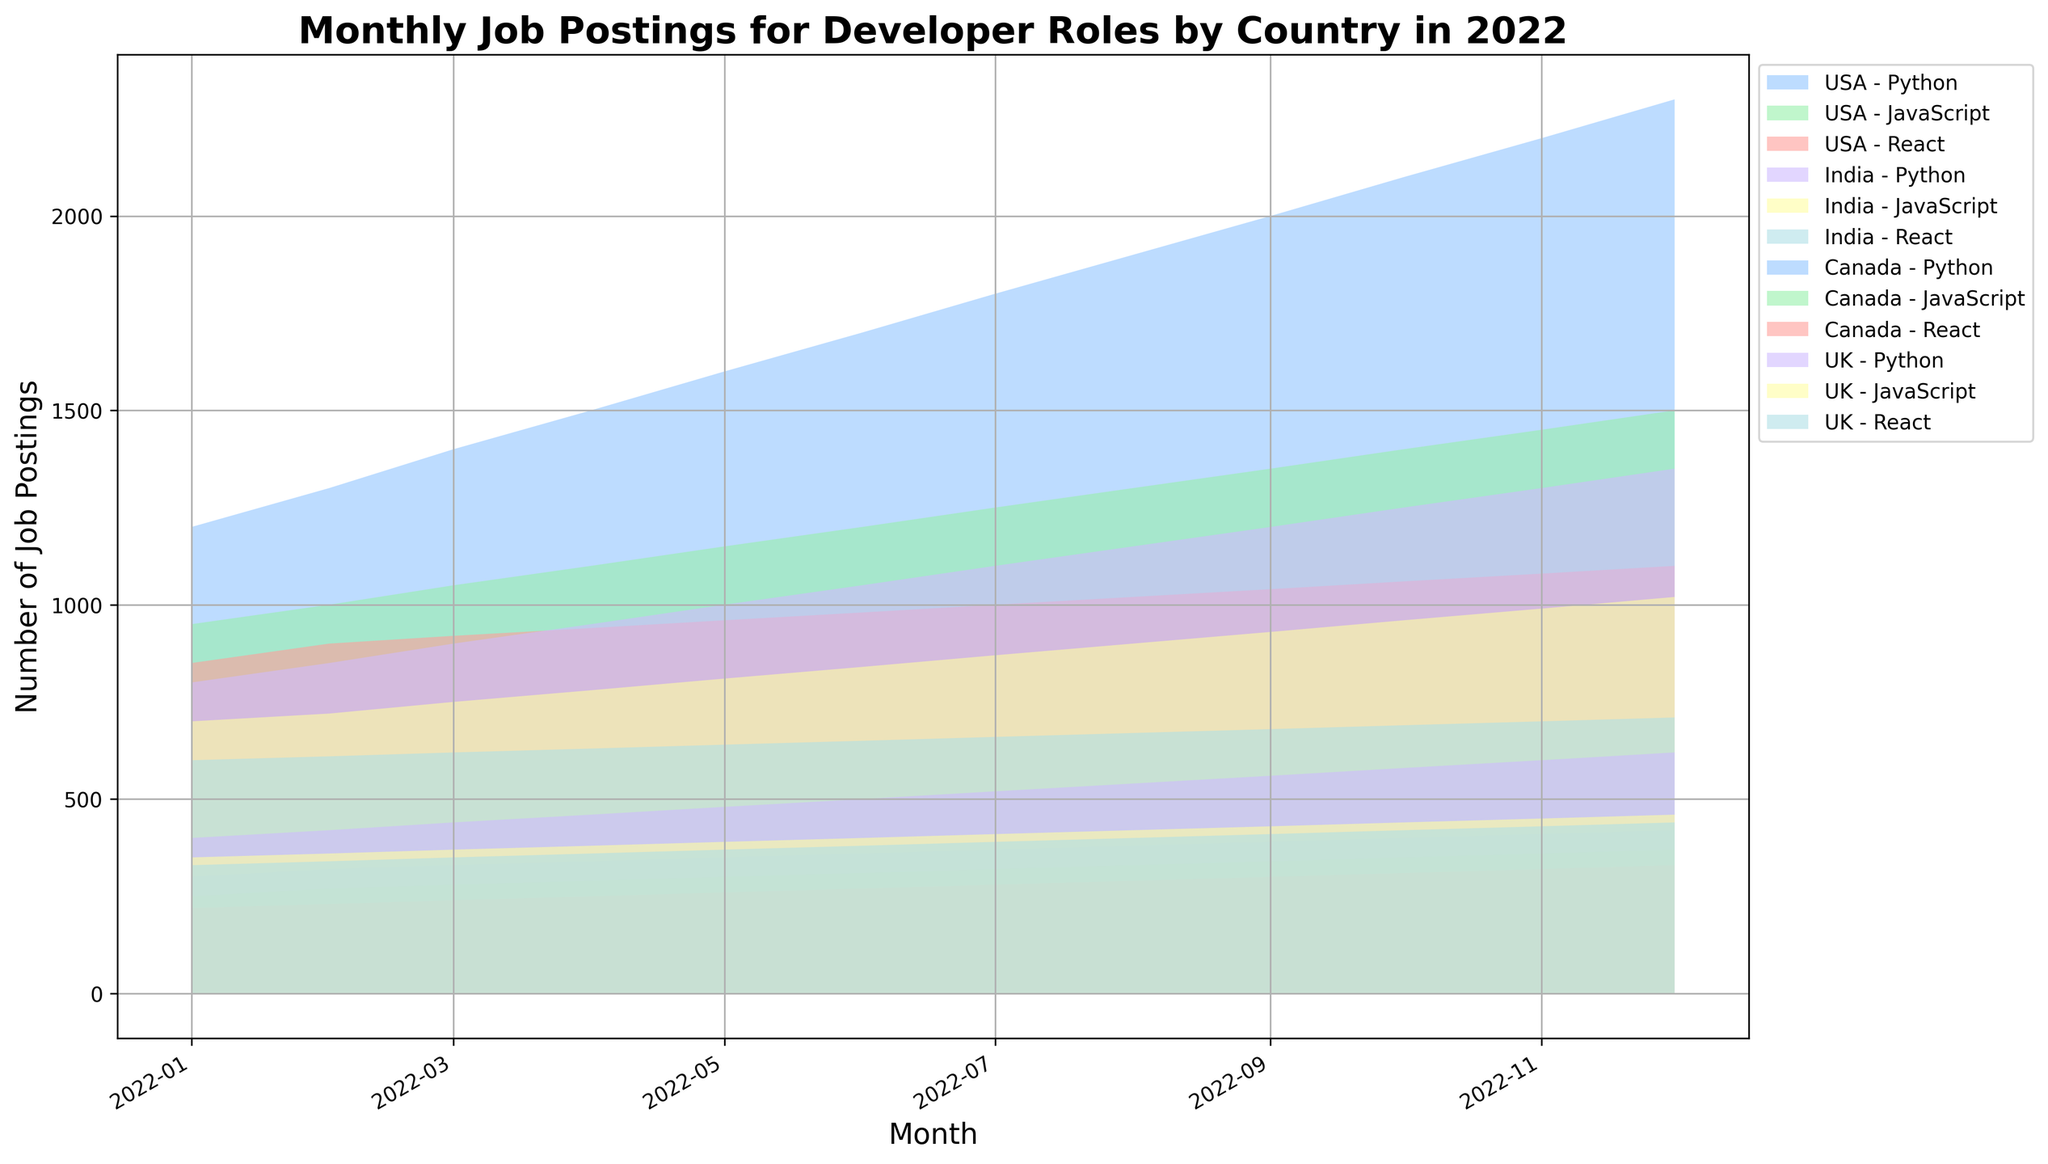Which country had the highest number of Python job postings in December 2022? Looking at the graph for December 2022, identify the height of the area marked for Python job postings for each country. The USA's area is the tallest.
Answer: USA How did the number of JavaScript job postings in India change from January to December 2022? Identify the beginning and end of the period (January and December) for JavaScript job postings in India. January has 700 job postings and December has 1020 job postings, indicating an increase.
Answer: Increased Which country showed the least growth in React job postings over the year 2022? Look for the smallest difference in the height of the area representing React job postings from January to December for each country. Canada shows the smallest increase.
Answer: Canada What is the total number of job postings (Python, JavaScript, and React combined) in the UK in April 2022? For April 2022 in the UK, sum the values of Python (460), JavaScript (380), and React (360) job postings. 460 + 380 + 360 = 1200.
Answer: 1200 Did the number of job postings for all roles (Python, JavaScript, and React) in the USA decrease at any time during 2022? Check the trend for the USA where the combined areas for Python, JavaScript, and React decrease from one month to the next. There is no decrease; the trend only increases.
Answer: No How do the Python job postings in Canada in March 2022 compare to those in India in the same month? Compare the height of the area for Python job postings for Canada and India in March 2022. Canada has 330 job postings, and India has 900 job postings, making India's higher.
Answer: India has more Which month had the highest combined number of job postings for all roles in the USA? Identify the month where the sum of the heights for Python, JavaScript, and React job postings in the USA is the largest. December 2022 has the highest combined number.
Answer: December 2022 How much did the number of React job postings in the UK increase from January to December 2022? Determine the number of React job postings in the UK for January (330) and December (440), then calculate the difference: 440 - 330 = 110.
Answer: 110 In which month did Canada first surpass 300 job postings for JavaScript roles? Identify the first month where the area representing JavaScript job postings in Canada exceeds 300. This happens in June 2022.
Answer: June 2022 Which country had more Python job postings than JavaScript job postings in every month of 2022? Compare the height of the areas for Python and JavaScript job postings for each country across all months. The USA consistently has more Python job postings than JavaScript.
Answer: USA 